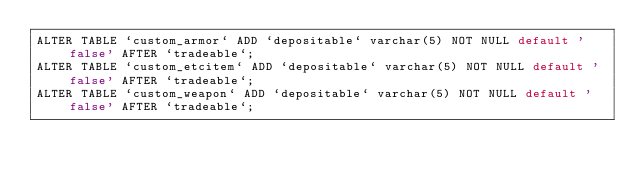<code> <loc_0><loc_0><loc_500><loc_500><_SQL_>ALTER TABLE `custom_armor` ADD `depositable` varchar(5) NOT NULL default 'false' AFTER `tradeable`;
ALTER TABLE `custom_etcitem` ADD `depositable` varchar(5) NOT NULL default 'false' AFTER `tradeable`;
ALTER TABLE `custom_weapon` ADD `depositable` varchar(5) NOT NULL default 'false' AFTER `tradeable`;</code> 